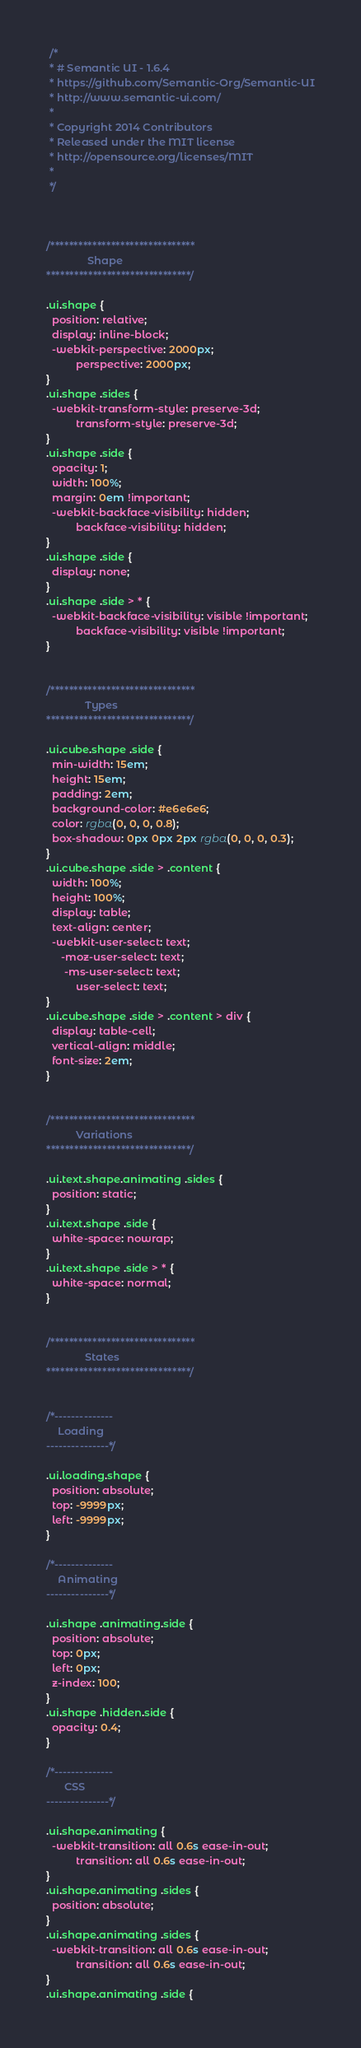<code> <loc_0><loc_0><loc_500><loc_500><_CSS_> /*
 * # Semantic UI - 1.6.4
 * https://github.com/Semantic-Org/Semantic-UI
 * http://www.semantic-ui.com/
 *
 * Copyright 2014 Contributors
 * Released under the MIT license
 * http://opensource.org/licenses/MIT
 *
 */



/*******************************
              Shape
*******************************/

.ui.shape {
  position: relative;
  display: inline-block;
  -webkit-perspective: 2000px;
          perspective: 2000px;
}
.ui.shape .sides {
  -webkit-transform-style: preserve-3d;
          transform-style: preserve-3d;
}
.ui.shape .side {
  opacity: 1;
  width: 100%;
  margin: 0em !important;
  -webkit-backface-visibility: hidden;
          backface-visibility: hidden;
}
.ui.shape .side {
  display: none;
}
.ui.shape .side > * {
  -webkit-backface-visibility: visible !important;
          backface-visibility: visible !important;
}


/*******************************
             Types
*******************************/

.ui.cube.shape .side {
  min-width: 15em;
  height: 15em;
  padding: 2em;
  background-color: #e6e6e6;
  color: rgba(0, 0, 0, 0.8);
  box-shadow: 0px 0px 2px rgba(0, 0, 0, 0.3);
}
.ui.cube.shape .side > .content {
  width: 100%;
  height: 100%;
  display: table;
  text-align: center;
  -webkit-user-select: text;
     -moz-user-select: text;
      -ms-user-select: text;
          user-select: text;
}
.ui.cube.shape .side > .content > div {
  display: table-cell;
  vertical-align: middle;
  font-size: 2em;
}


/*******************************
          Variations
*******************************/

.ui.text.shape.animating .sides {
  position: static;
}
.ui.text.shape .side {
  white-space: nowrap;
}
.ui.text.shape .side > * {
  white-space: normal;
}


/*******************************
             States
*******************************/


/*--------------
    Loading
---------------*/

.ui.loading.shape {
  position: absolute;
  top: -9999px;
  left: -9999px;
}

/*--------------
    Animating
---------------*/

.ui.shape .animating.side {
  position: absolute;
  top: 0px;
  left: 0px;
  z-index: 100;
}
.ui.shape .hidden.side {
  opacity: 0.4;
}

/*--------------
      CSS
---------------*/

.ui.shape.animating {
  -webkit-transition: all 0.6s ease-in-out;
          transition: all 0.6s ease-in-out;
}
.ui.shape.animating .sides {
  position: absolute;
}
.ui.shape.animating .sides {
  -webkit-transition: all 0.6s ease-in-out;
          transition: all 0.6s ease-in-out;
}
.ui.shape.animating .side {</code> 